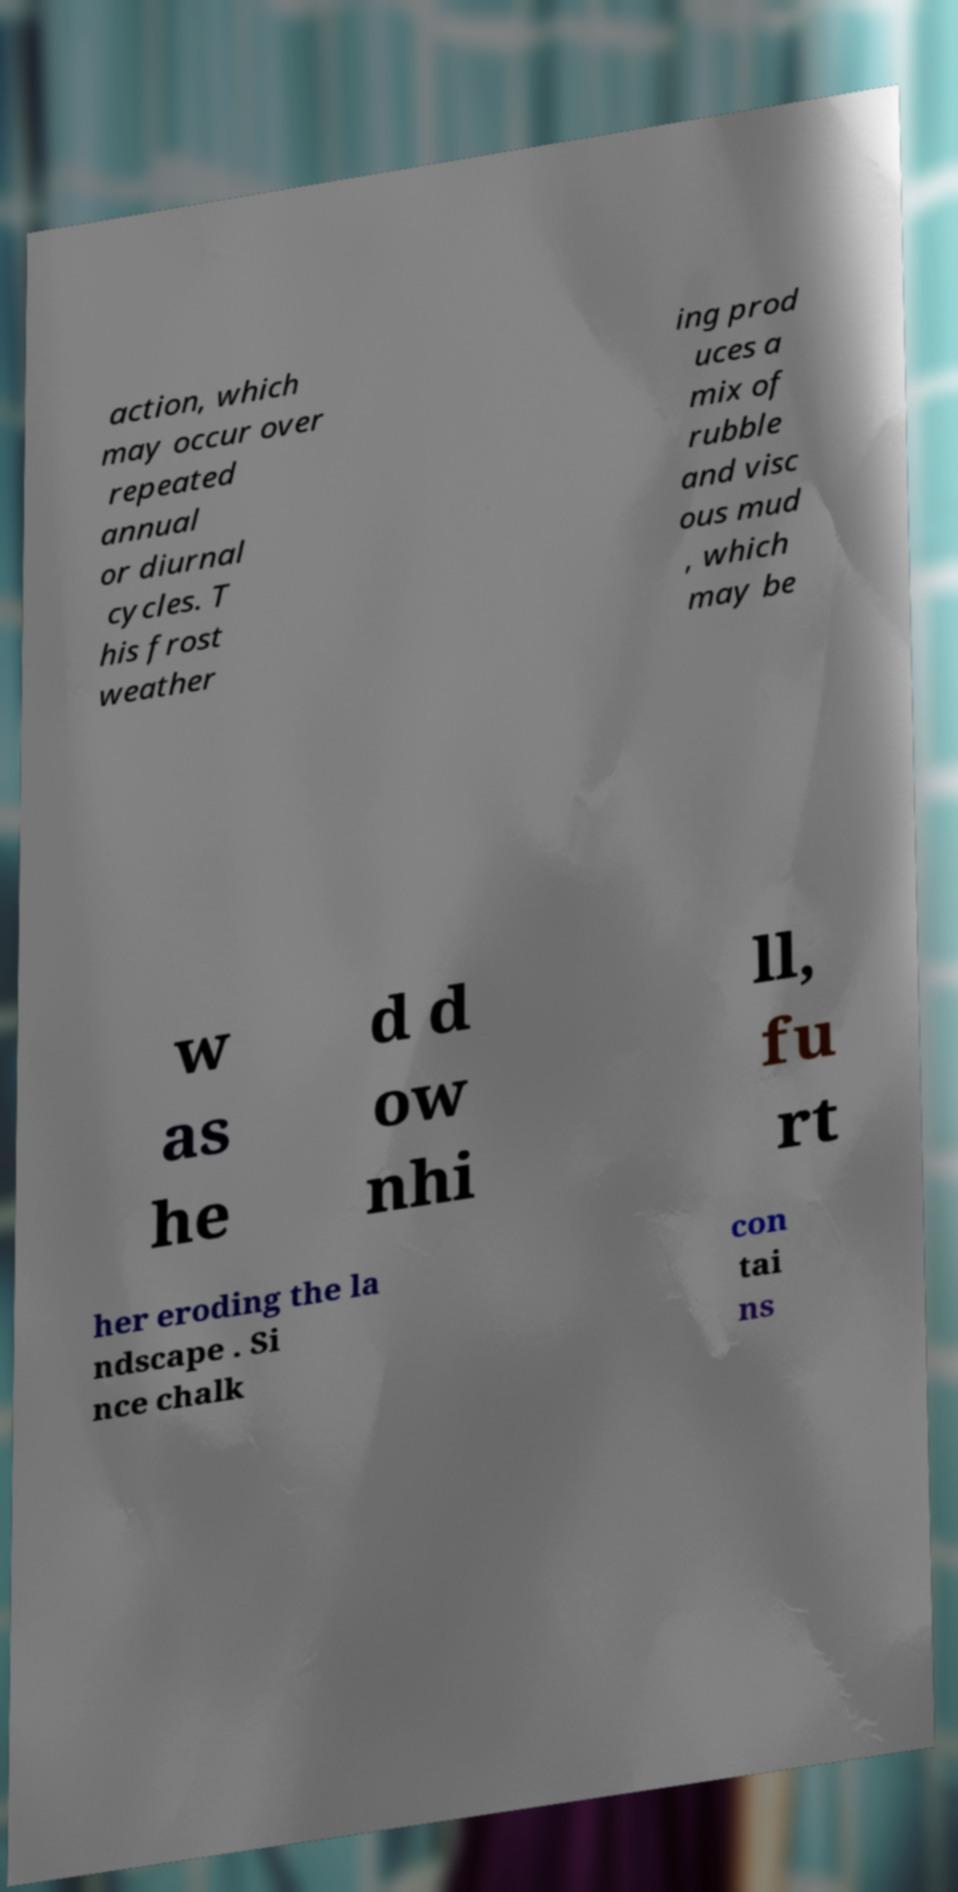For documentation purposes, I need the text within this image transcribed. Could you provide that? action, which may occur over repeated annual or diurnal cycles. T his frost weather ing prod uces a mix of rubble and visc ous mud , which may be w as he d d ow nhi ll, fu rt her eroding the la ndscape . Si nce chalk con tai ns 